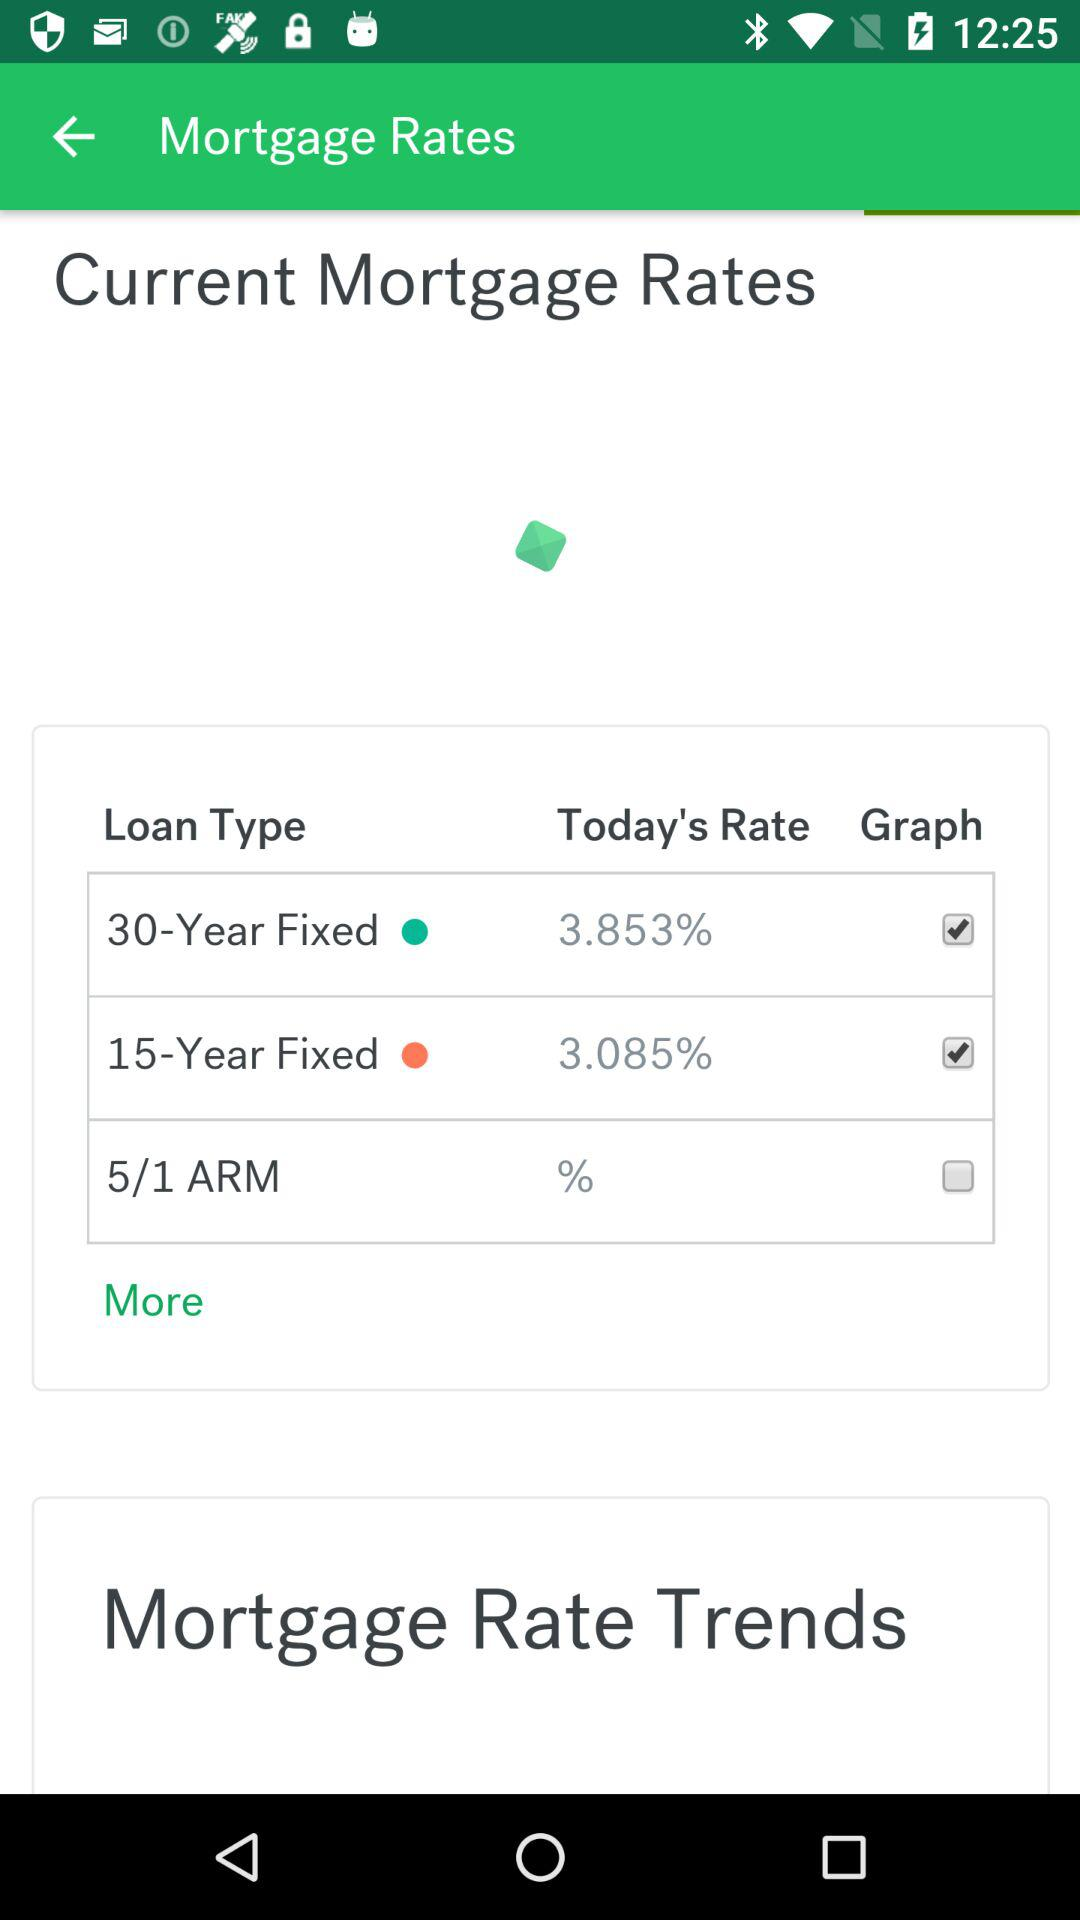What is the current status of the "15-Year Fixed" loan type? The status is "on". 